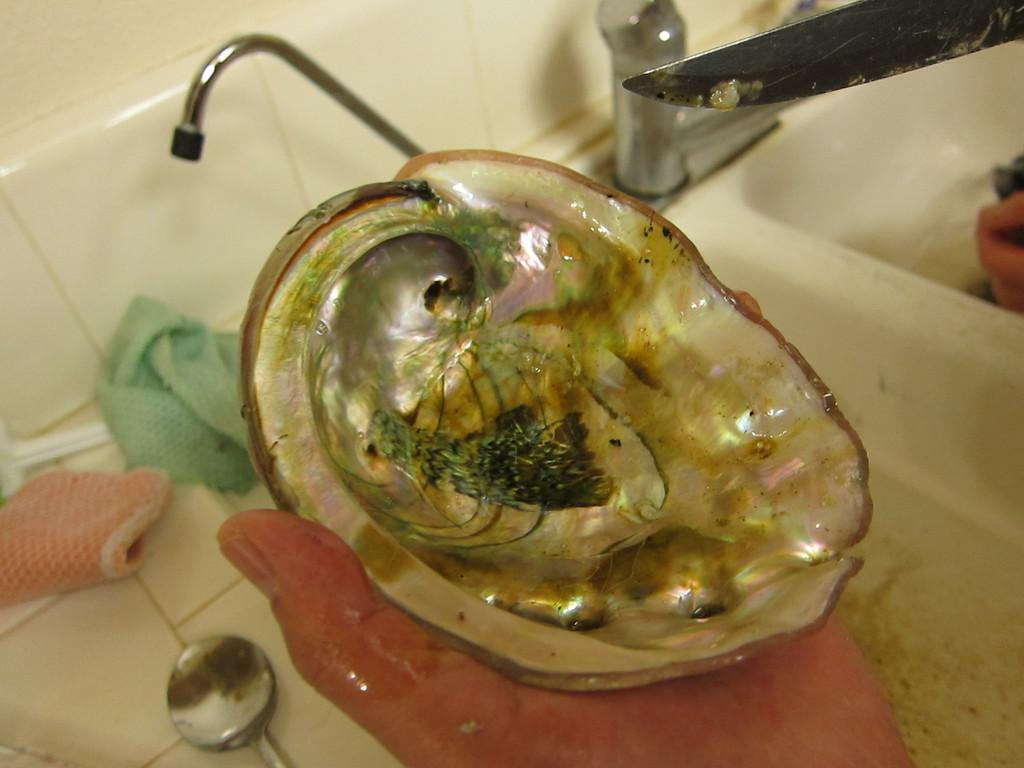What is the human hand holding in the image? The human hand is holding a seashell in the image. What can be seen near the human hand? There is a water tap and a wash basin in the image. What utensils are present in the image? There is a spoon, a knife, and napkins in the image. What is the background of the image? There is a wall in the image. What type of fruit is the daughter holding in the image? There is no daughter or fruit present in the image. 